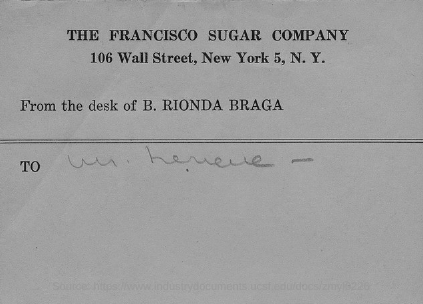Who is the desk?
Your response must be concise. B. RIONDA BRAGA. 